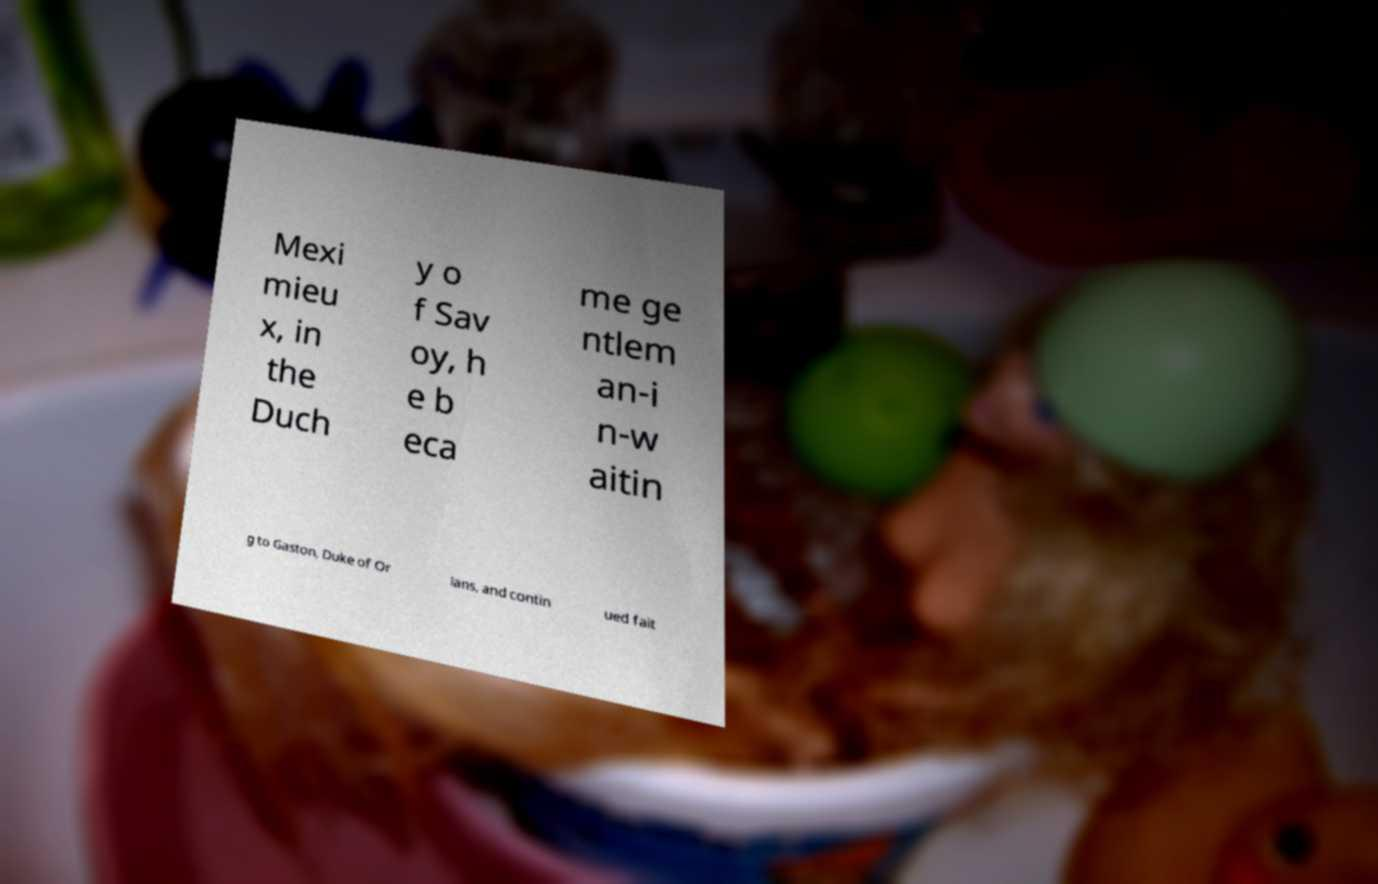Could you extract and type out the text from this image? Mexi mieu x, in the Duch y o f Sav oy, h e b eca me ge ntlem an-i n-w aitin g to Gaston, Duke of Or lans, and contin ued fait 